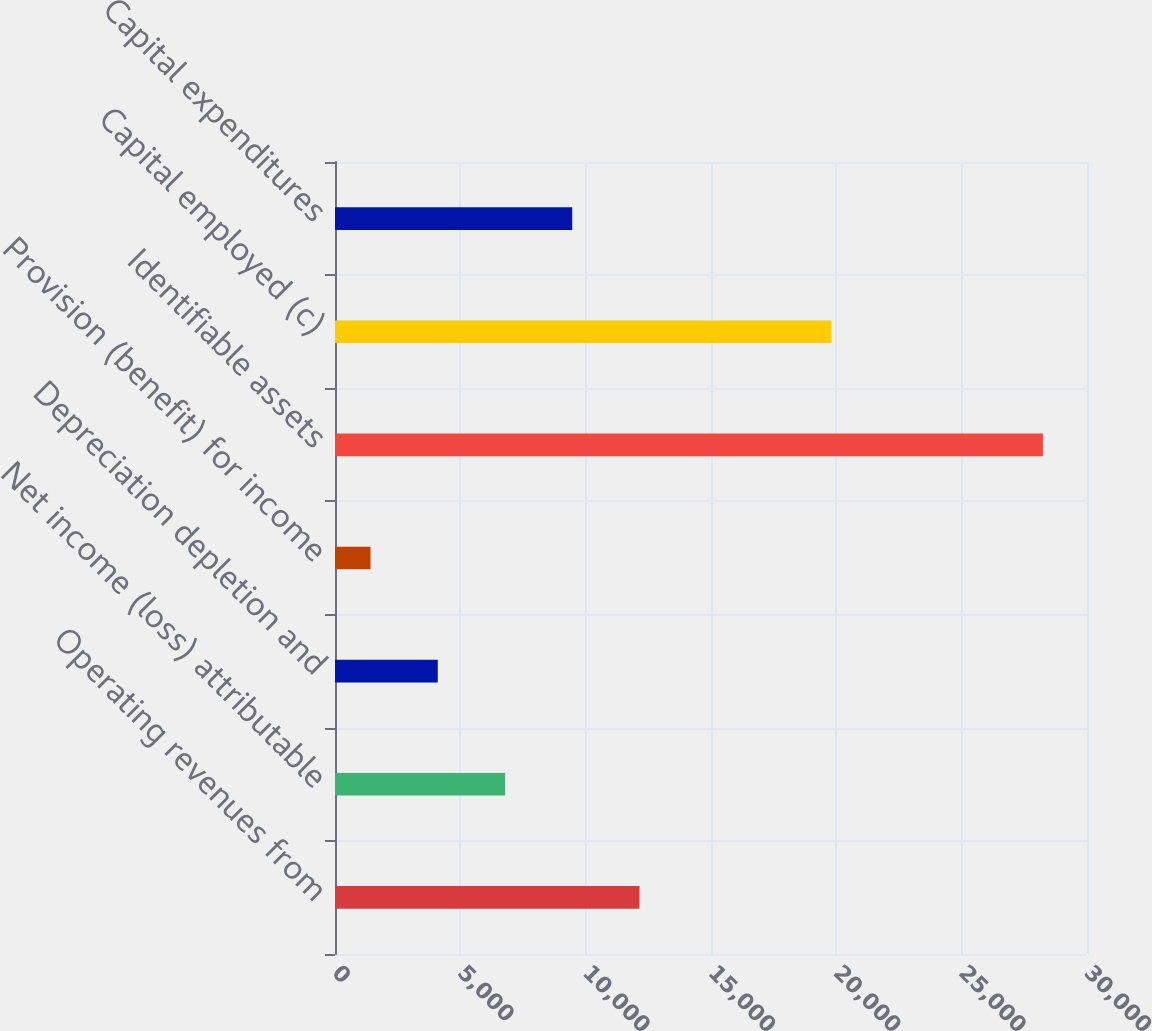Convert chart. <chart><loc_0><loc_0><loc_500><loc_500><bar_chart><fcel>Operating revenues from<fcel>Net income (loss) attributable<fcel>Depreciation depletion and<fcel>Provision (benefit) for income<fcel>Identifiable assets<fcel>Capital employed (c)<fcel>Capital expenditures<nl><fcel>12147<fcel>6782<fcel>4099.5<fcel>1417<fcel>28242<fcel>19803<fcel>9464.5<nl></chart> 